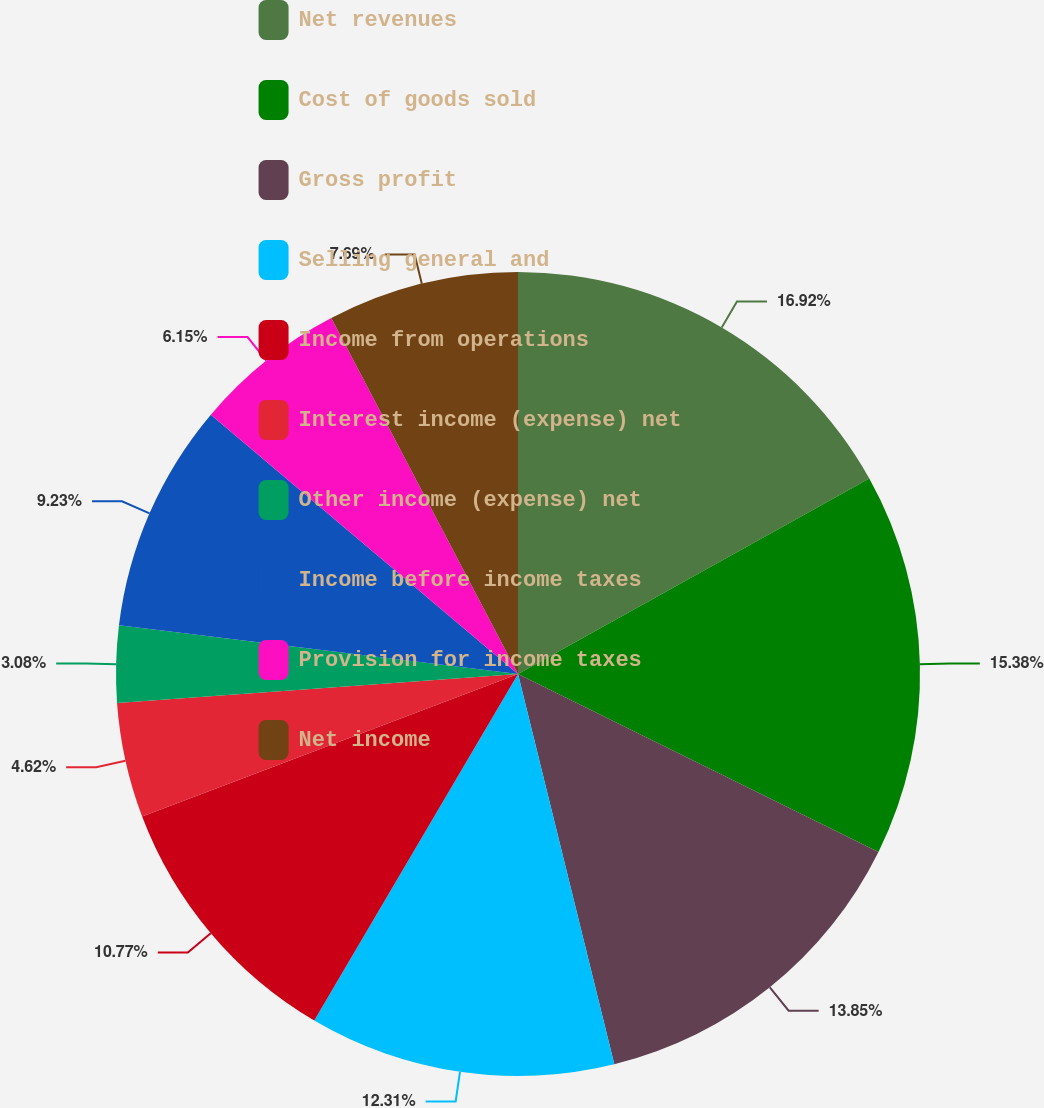Convert chart. <chart><loc_0><loc_0><loc_500><loc_500><pie_chart><fcel>Net revenues<fcel>Cost of goods sold<fcel>Gross profit<fcel>Selling general and<fcel>Income from operations<fcel>Interest income (expense) net<fcel>Other income (expense) net<fcel>Income before income taxes<fcel>Provision for income taxes<fcel>Net income<nl><fcel>16.92%<fcel>15.38%<fcel>13.85%<fcel>12.31%<fcel>10.77%<fcel>4.62%<fcel>3.08%<fcel>9.23%<fcel>6.15%<fcel>7.69%<nl></chart> 